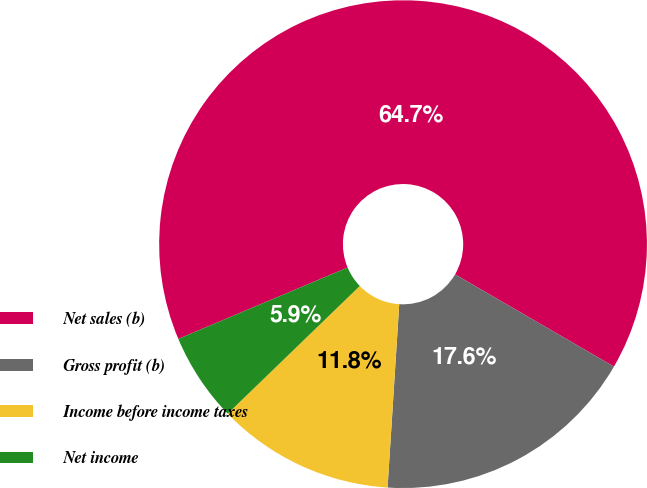Convert chart to OTSL. <chart><loc_0><loc_0><loc_500><loc_500><pie_chart><fcel>Net sales (b)<fcel>Gross profit (b)<fcel>Income before income taxes<fcel>Net income<nl><fcel>64.72%<fcel>17.64%<fcel>11.76%<fcel>5.88%<nl></chart> 